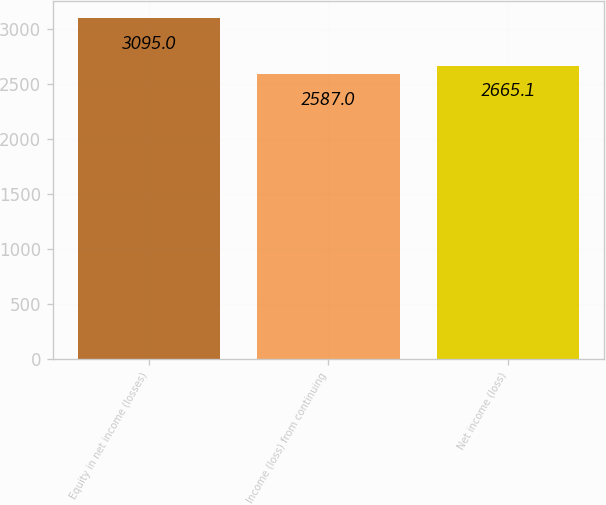Convert chart to OTSL. <chart><loc_0><loc_0><loc_500><loc_500><bar_chart><fcel>Equity in net income (losses)<fcel>Income (loss) from continuing<fcel>Net income (loss)<nl><fcel>3095<fcel>2587<fcel>2665.1<nl></chart> 